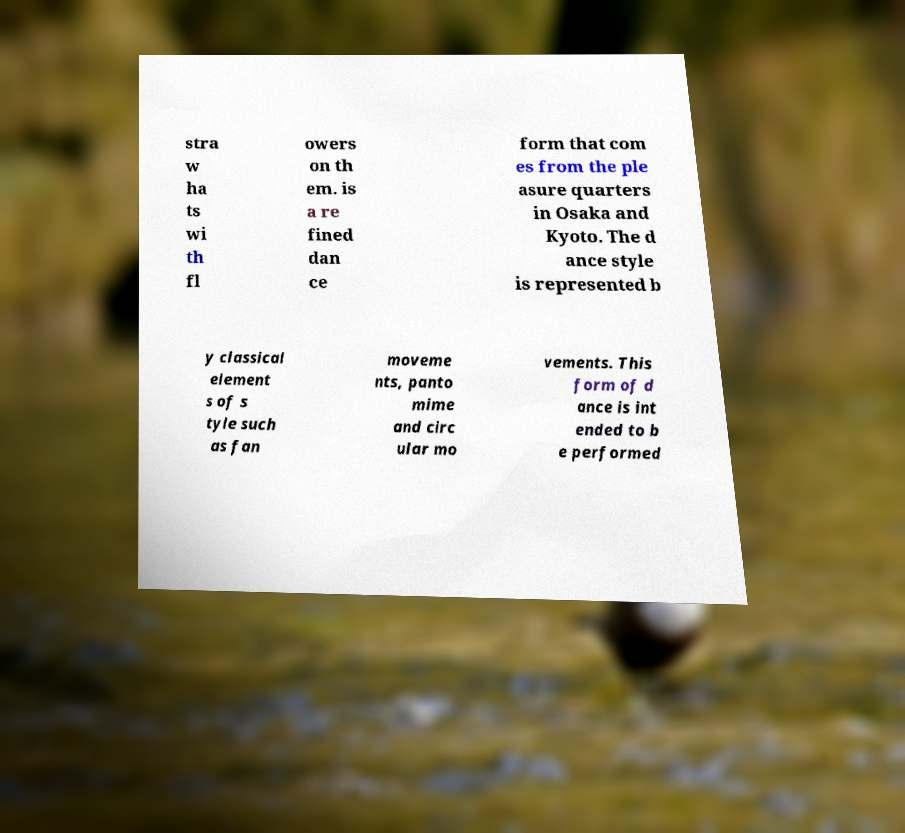For documentation purposes, I need the text within this image transcribed. Could you provide that? stra w ha ts wi th fl owers on th em. is a re fined dan ce form that com es from the ple asure quarters in Osaka and Kyoto. The d ance style is represented b y classical element s of s tyle such as fan moveme nts, panto mime and circ ular mo vements. This form of d ance is int ended to b e performed 